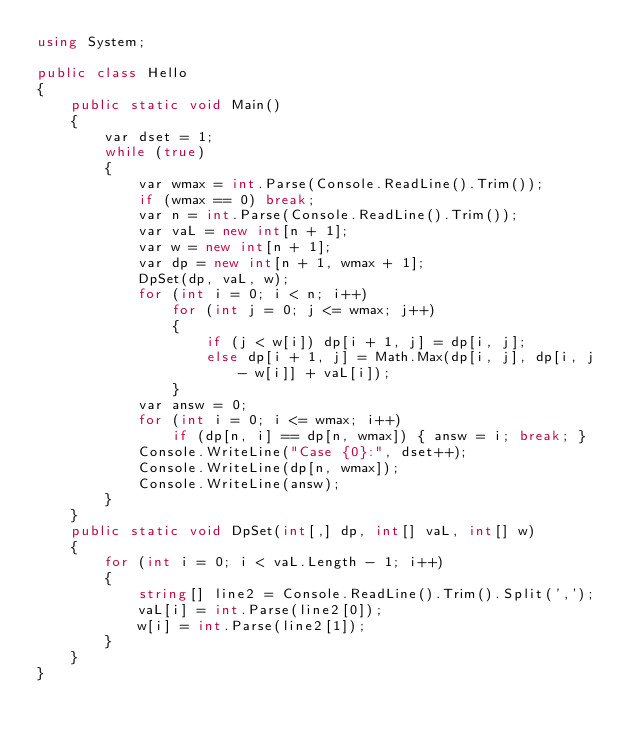<code> <loc_0><loc_0><loc_500><loc_500><_C#_>using System;

public class Hello
{
    public static void Main()
    {
        var dset = 1;
        while (true)
        {
            var wmax = int.Parse(Console.ReadLine().Trim());
            if (wmax == 0) break;
            var n = int.Parse(Console.ReadLine().Trim());
            var vaL = new int[n + 1];
            var w = new int[n + 1];
            var dp = new int[n + 1, wmax + 1];
            DpSet(dp, vaL, w);
            for (int i = 0; i < n; i++)
                for (int j = 0; j <= wmax; j++)
                {
                    if (j < w[i]) dp[i + 1, j] = dp[i, j];
                    else dp[i + 1, j] = Math.Max(dp[i, j], dp[i, j - w[i]] + vaL[i]);
                }
            var answ = 0;
            for (int i = 0; i <= wmax; i++)
                if (dp[n, i] == dp[n, wmax]) { answ = i; break; }
            Console.WriteLine("Case {0}:", dset++);
            Console.WriteLine(dp[n, wmax]);
            Console.WriteLine(answ);
        }
    }
    public static void DpSet(int[,] dp, int[] vaL, int[] w)
    {
        for (int i = 0; i < vaL.Length - 1; i++)
        {
            string[] line2 = Console.ReadLine().Trim().Split(',');
            vaL[i] = int.Parse(line2[0]);
            w[i] = int.Parse(line2[1]);
        }
    }
}</code> 